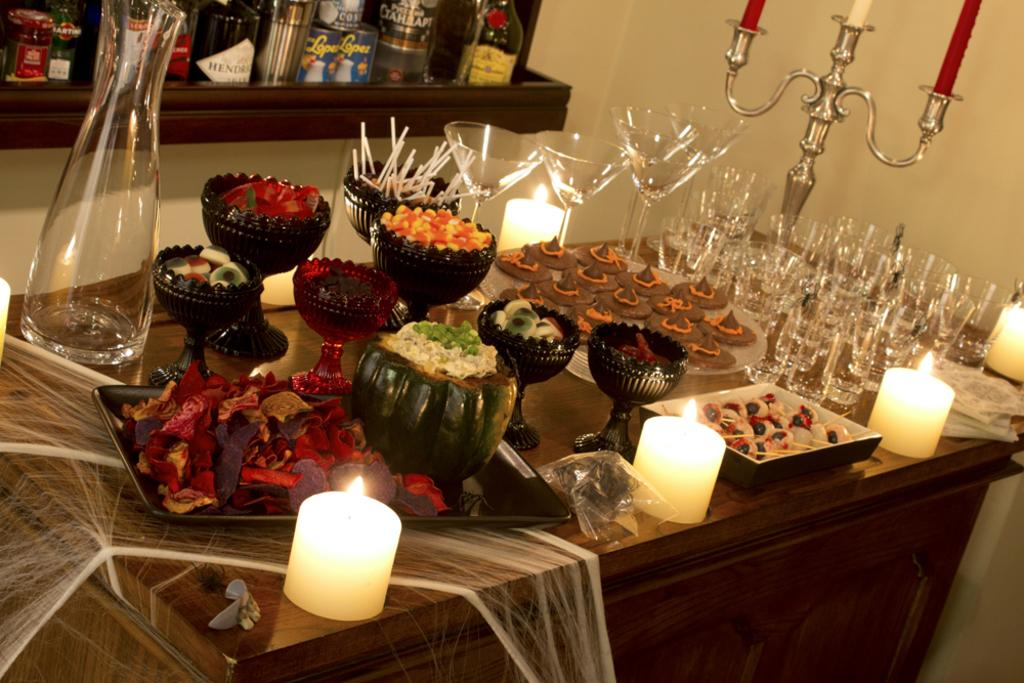What type of furniture is present in the image? There is a table in the image. What can be found on the table? There are food items, glasses, and candles on the table. What color crayon is being used to draw on the table in the image? There are no crayons present in the image, and therefore no drawing can be observed. 